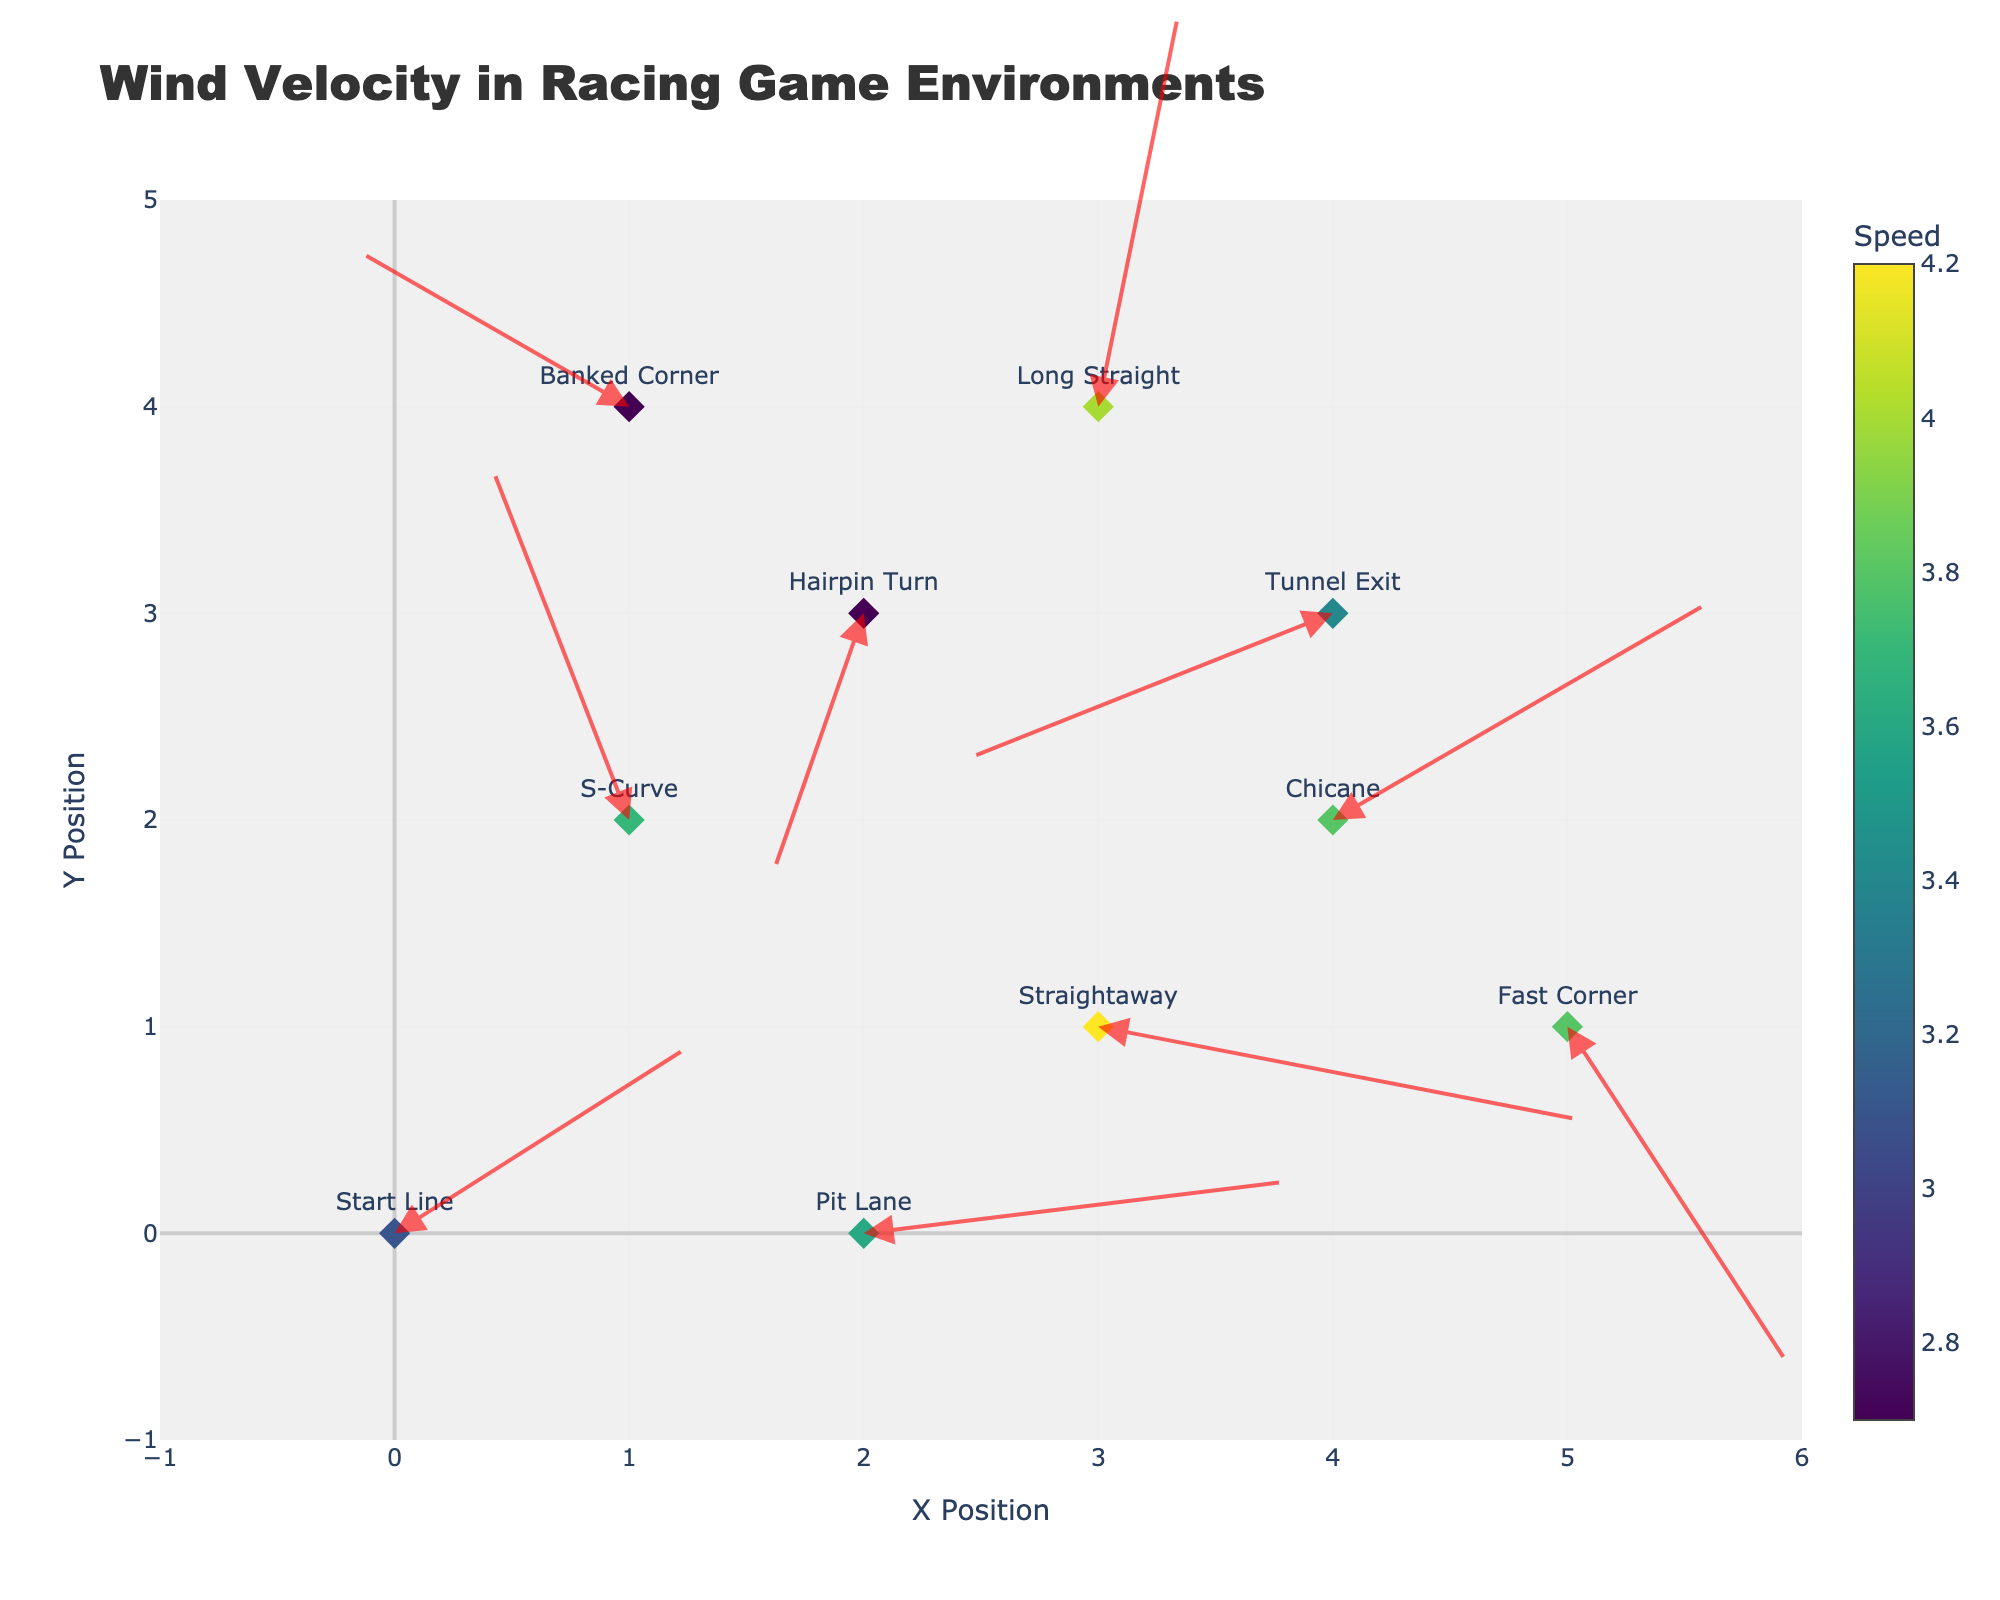What's the title of the plot? The title is displayed at the top of the plot and provides insight into what the plot represents. In this case, it is "Wind Velocity in Racing Game Environments."
Answer: Wind Velocity in Racing Game Environments How many data points are there on the plot? The plot has multiple markers corresponding to different locations. Counting these markers reveals the total number of data points.
Answer: 10 What is the speed at the "Chicane" area? By identifying the data point labeled "Chicane," we refer to the color scale or the hover information to find out the corresponding speed.
Answer: 3.8 Which area has the highest wind speed? By examining the color scale or the hover information, we compare the speeds of all areas and identify the highest value. The "Straightaway" area has the highest speed.
Answer: Straightaway Which direction is the wind blowing at the "Pit Lane"? By locating the "Pit Lane" data point and observing the direction of the arrow originating from it, we can determine the wind direction. The arrow points mostly rightwards and slightly upwards.
Answer: Rightwards with a slight upward tilt Compare the wind speed at "S-Curve" and "Banked Corner." Which is higher? Find the "S-Curve" and "Banked Corner" data points, refer to their speeds and compare the numbers. "S-Curve" has a speed of 3.7, while "Banked Corner" has 2.7.
Answer: S-Curve What is the range of x-axis values in the plot? The x-axis scale on the plot shows the minimum and maximum values depicted on this axis.
Answer: -1 to 6 Which data point has the least negative u-component of velocity? The u-component represents horizontal velocity. Look for the least negative value (or the closest to zero) among the negative u-values. The "Hairpin Turn" with u = -0.8 has the least negative value.
Answer: Hairpin Turn How many areas have the u-component of velocity greater than 3? Examine the u-values and count those greater than 3. This applies to the "Straightaway" and "Pit Lane."
Answer: 2 What is the average speed of all areas? Add all the speed values together and divide by the number of areas. (3.1 + 3.7 + 4.2 + 2.7 + 3.8 + 2.7 + 3.8 + 4.0 + 3.4 + 3.6) / 10 = 3.5
Answer: 3.5 